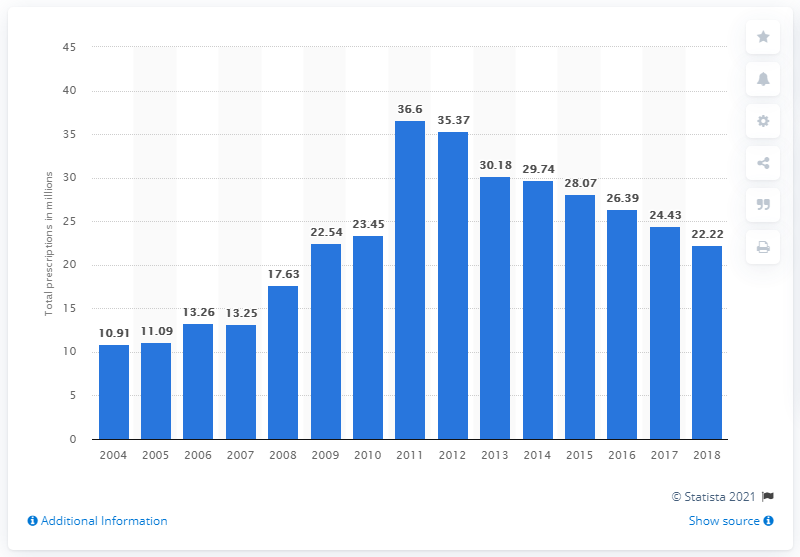Outline some significant characteristics in this image. In 2004, citalopram was prescribed a total of 10.91 times. 